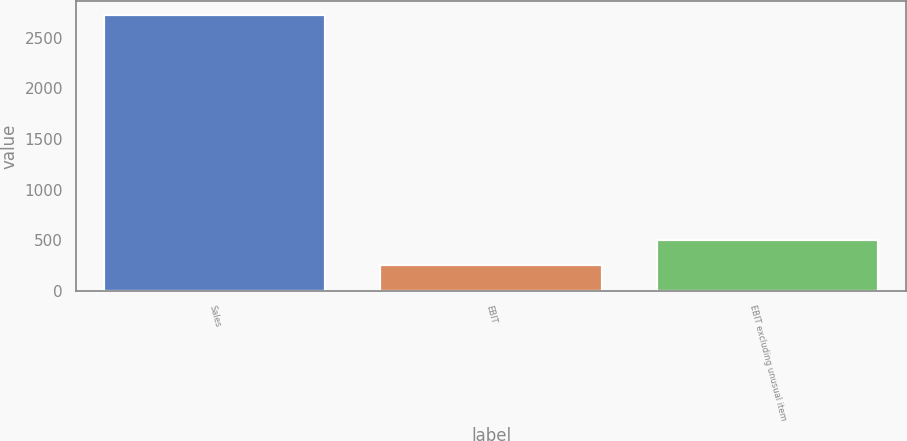Convert chart. <chart><loc_0><loc_0><loc_500><loc_500><bar_chart><fcel>Sales<fcel>EBIT<fcel>EBIT excluding unusual item<nl><fcel>2728<fcel>255<fcel>502.3<nl></chart> 